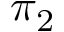<formula> <loc_0><loc_0><loc_500><loc_500>\pi _ { 2 }</formula> 